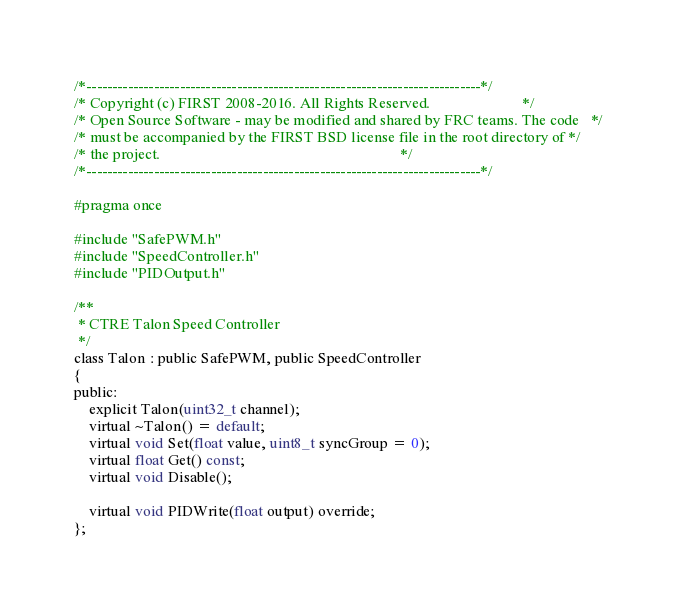<code> <loc_0><loc_0><loc_500><loc_500><_C_>/*----------------------------------------------------------------------------*/
/* Copyright (c) FIRST 2008-2016. All Rights Reserved.                        */
/* Open Source Software - may be modified and shared by FRC teams. The code   */
/* must be accompanied by the FIRST BSD license file in the root directory of */
/* the project.                                                               */
/*----------------------------------------------------------------------------*/

#pragma once

#include "SafePWM.h"
#include "SpeedController.h"
#include "PIDOutput.h"

/**
 * CTRE Talon Speed Controller
 */
class Talon : public SafePWM, public SpeedController
{
public:
	explicit Talon(uint32_t channel);
	virtual ~Talon() = default;
	virtual void Set(float value, uint8_t syncGroup = 0);
	virtual float Get() const;
	virtual void Disable();

	virtual void PIDWrite(float output) override;
};
</code> 